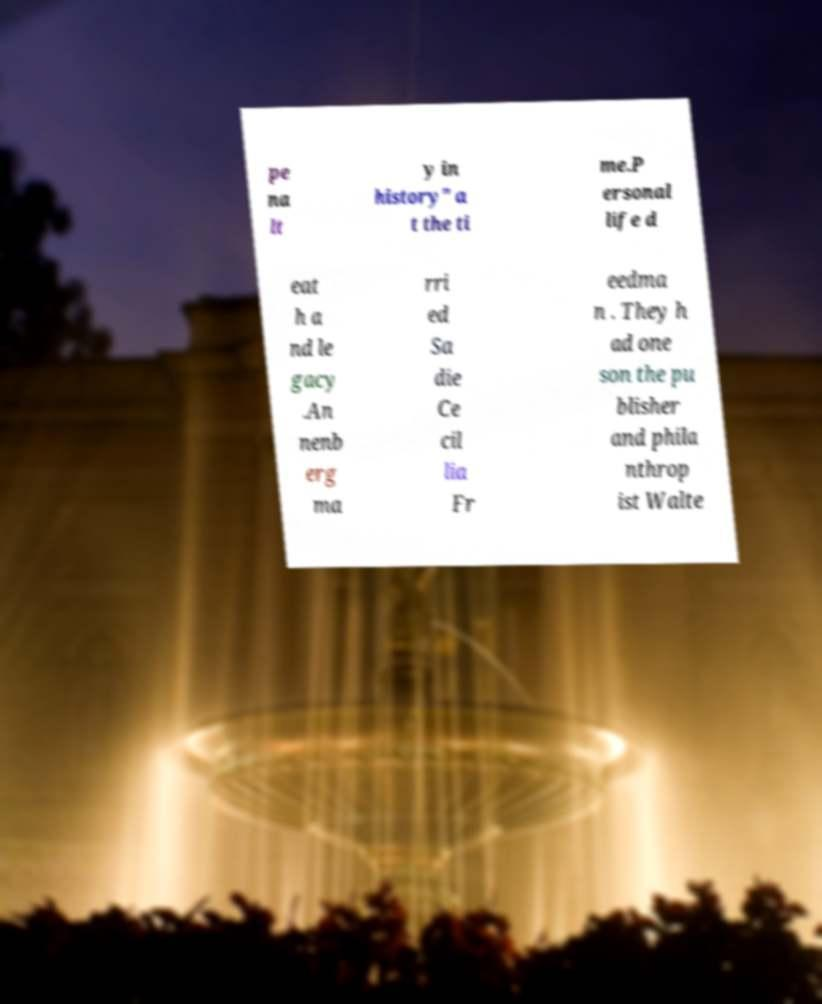Can you read and provide the text displayed in the image?This photo seems to have some interesting text. Can you extract and type it out for me? pe na lt y in history" a t the ti me.P ersonal life d eat h a nd le gacy .An nenb erg ma rri ed Sa die Ce cil lia Fr eedma n . They h ad one son the pu blisher and phila nthrop ist Walte 